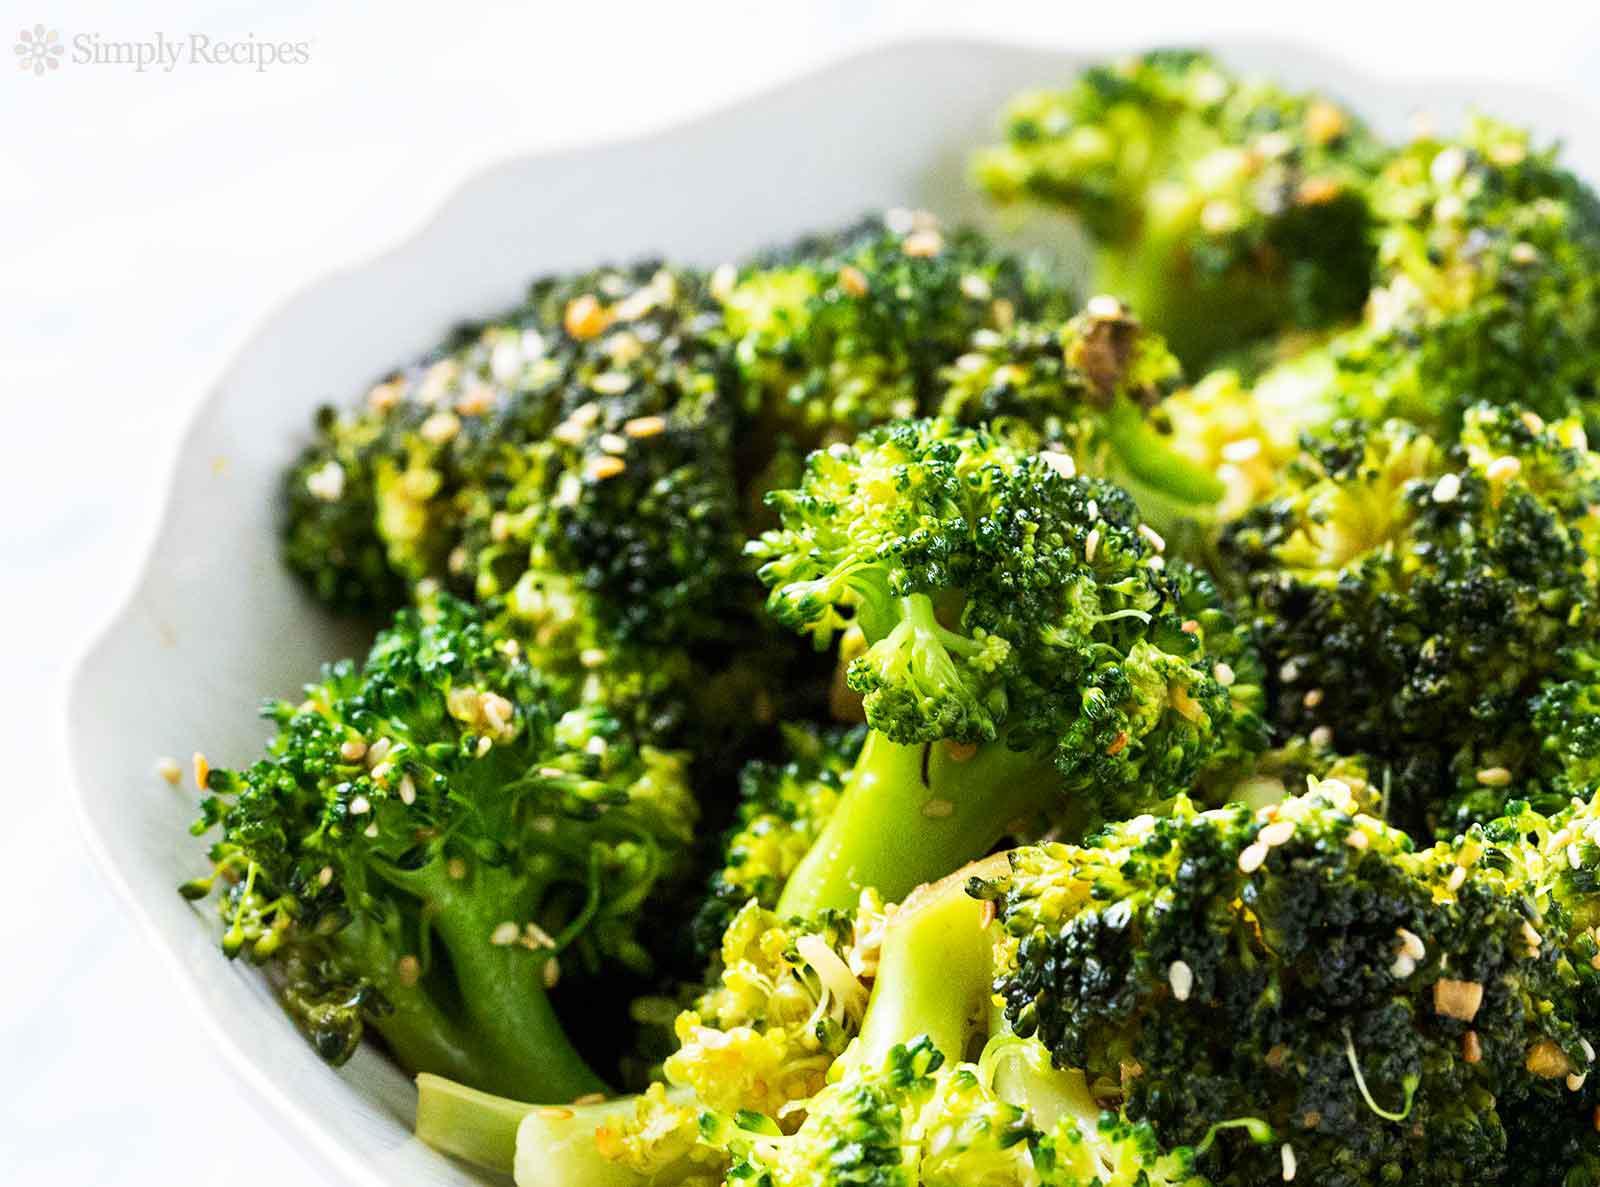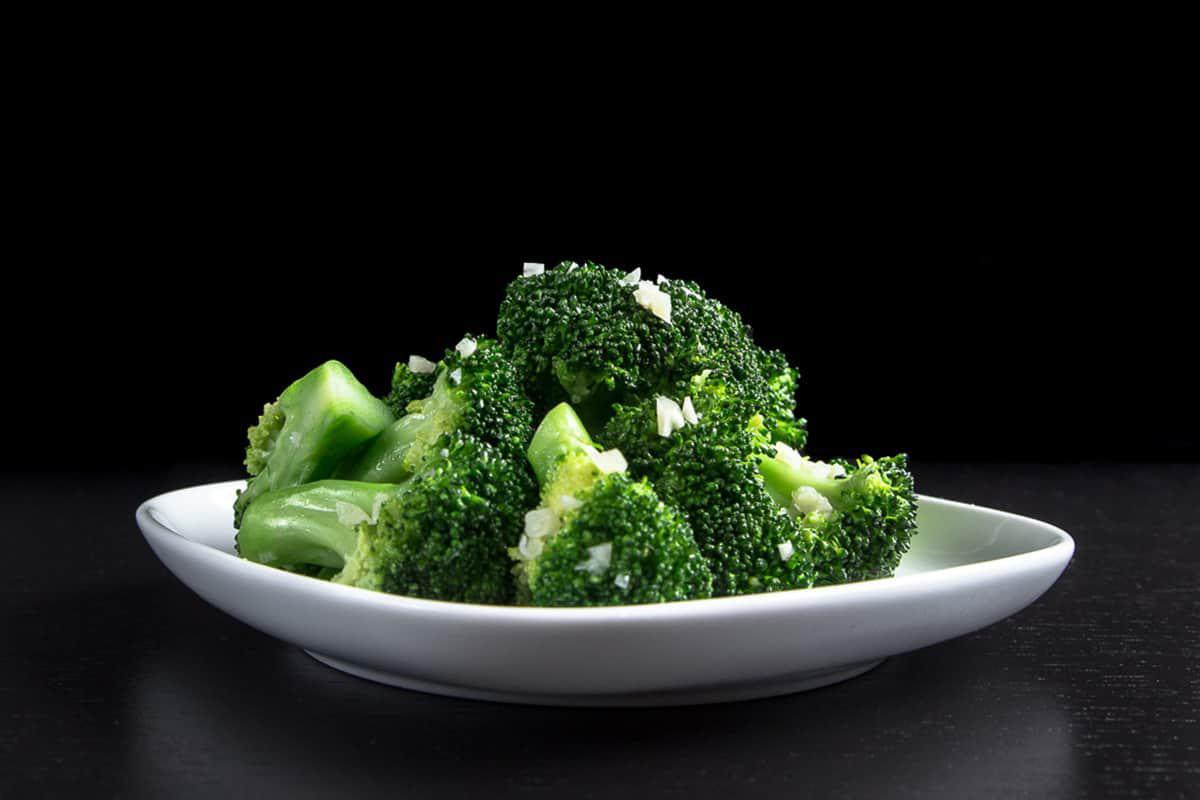The first image is the image on the left, the second image is the image on the right. Analyze the images presented: Is the assertion "The left and right image contains the same number of white plates with broccoli." valid? Answer yes or no. Yes. The first image is the image on the left, the second image is the image on the right. For the images shown, is this caption "In one image, broccoli florets are being steamed in a metal pot." true? Answer yes or no. No. 